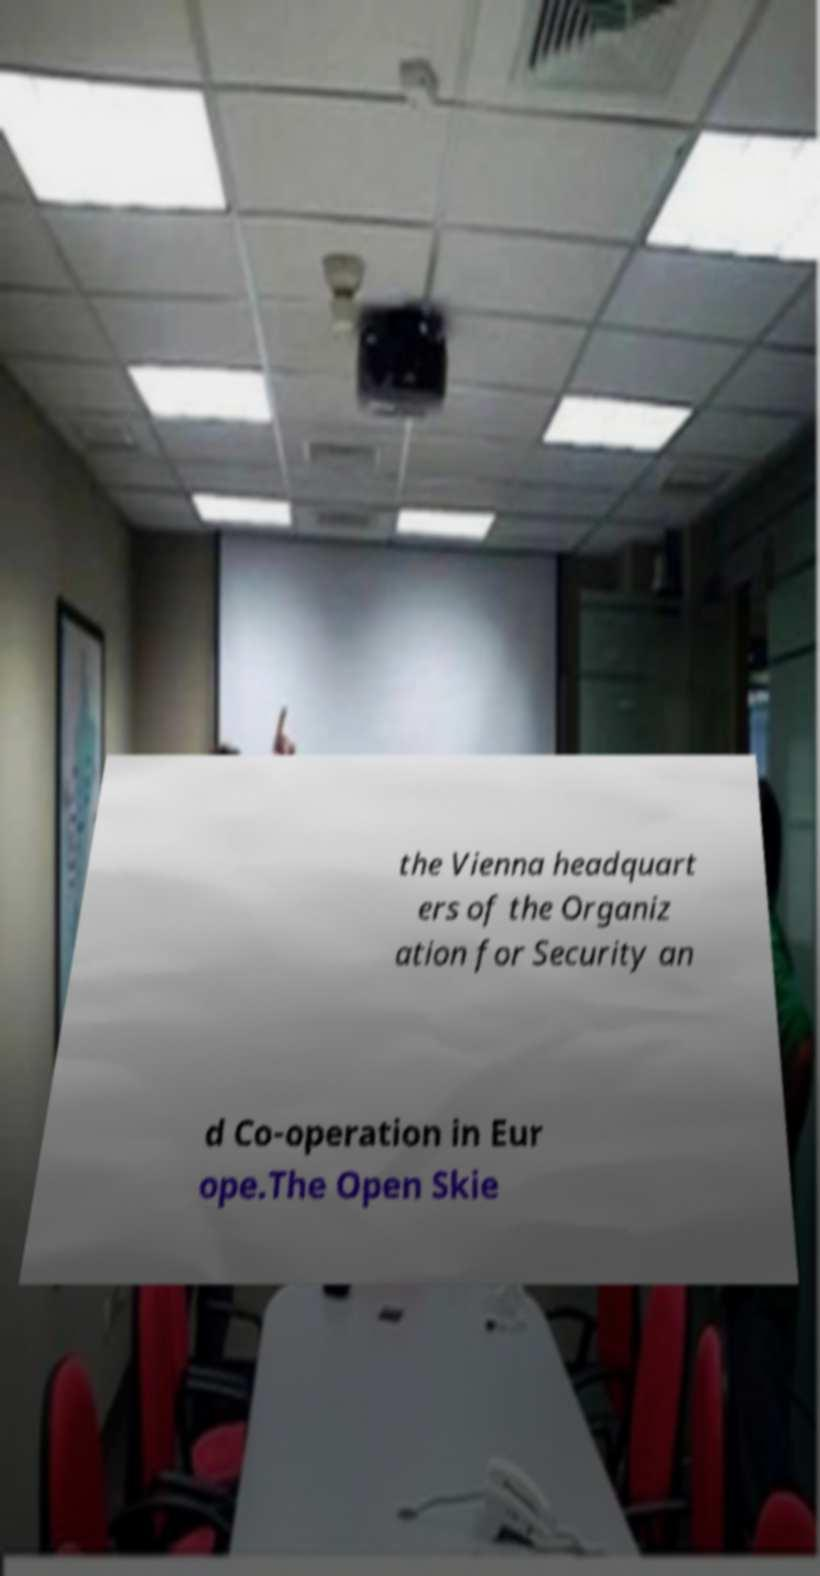Can you read and provide the text displayed in the image?This photo seems to have some interesting text. Can you extract and type it out for me? the Vienna headquart ers of the Organiz ation for Security an d Co-operation in Eur ope.The Open Skie 